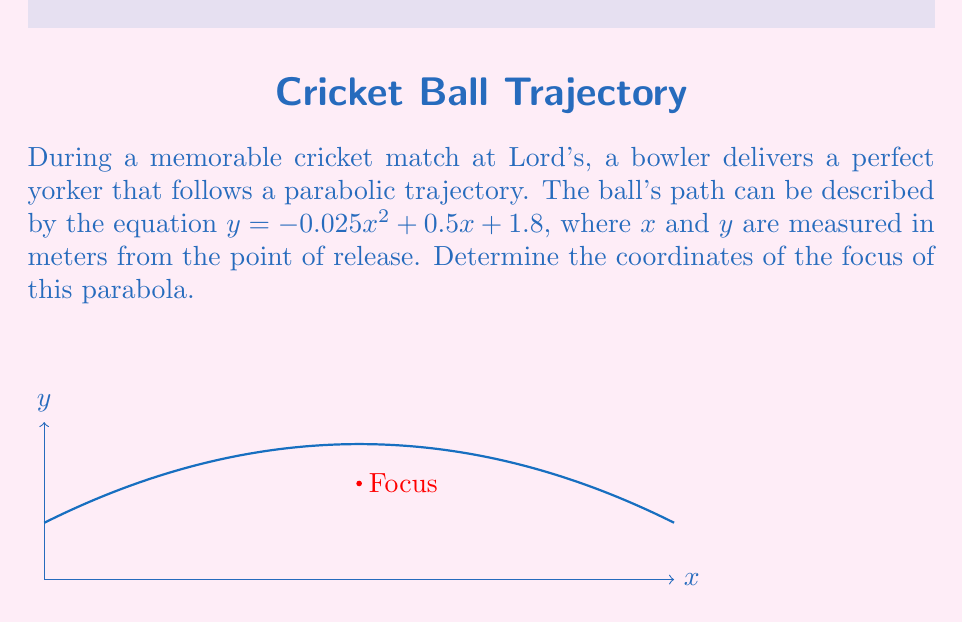Give your solution to this math problem. Let's approach this step-by-step:

1) The general form of a parabola with a vertical axis of symmetry is:
   $y = a(x-h)^2 + k$
   where $(h,k)$ is the vertex and $a$ determines the direction and width of the parabola.

2) Our parabola is in the form $y = ax^2 + bx + c$
   where $a = -0.025$, $b = 0.5$, and $c = 1.8$

3) To find the vertex, we use the formulas:
   $h = -\frac{b}{2a}$ and $k = f(h) = ah^2 + bh + c$

4) Calculating $h$:
   $h = -\frac{0.5}{2(-0.025)} = 10$

5) Calculating $k$:
   $k = -0.025(10)^2 + 0.5(10) + 1.8 = 3.05$

6) So the vertex is $(10, 3.05)$

7) For a parabola with equation $y = ax^2 + bx + c$, the focal length (distance from vertex to focus) is given by $\frac{1}{4a}$

8) In this case, the focal length is:
   $\frac{1}{4(-0.025)} = -10$

9) Since $a$ is negative, the parabola opens downward, so we subtract the focal length from the y-coordinate of the vertex to find the focus.

10) The focus is therefore at:
    $(10, 3.05 - 10) = (10, -6.95)$
Answer: $(10, -6.95)$ 